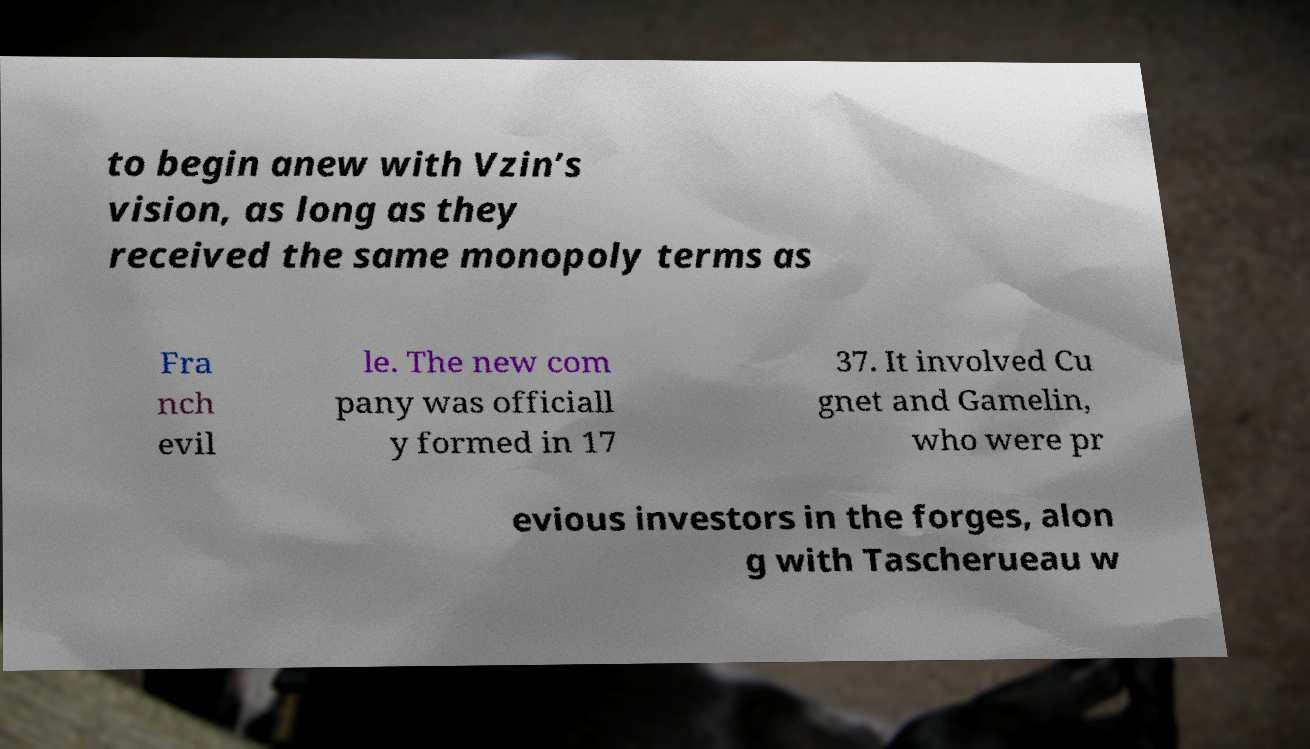I need the written content from this picture converted into text. Can you do that? to begin anew with Vzin’s vision, as long as they received the same monopoly terms as Fra nch evil le. The new com pany was officiall y formed in 17 37. It involved Cu gnet and Gamelin, who were pr evious investors in the forges, alon g with Tascherueau w 